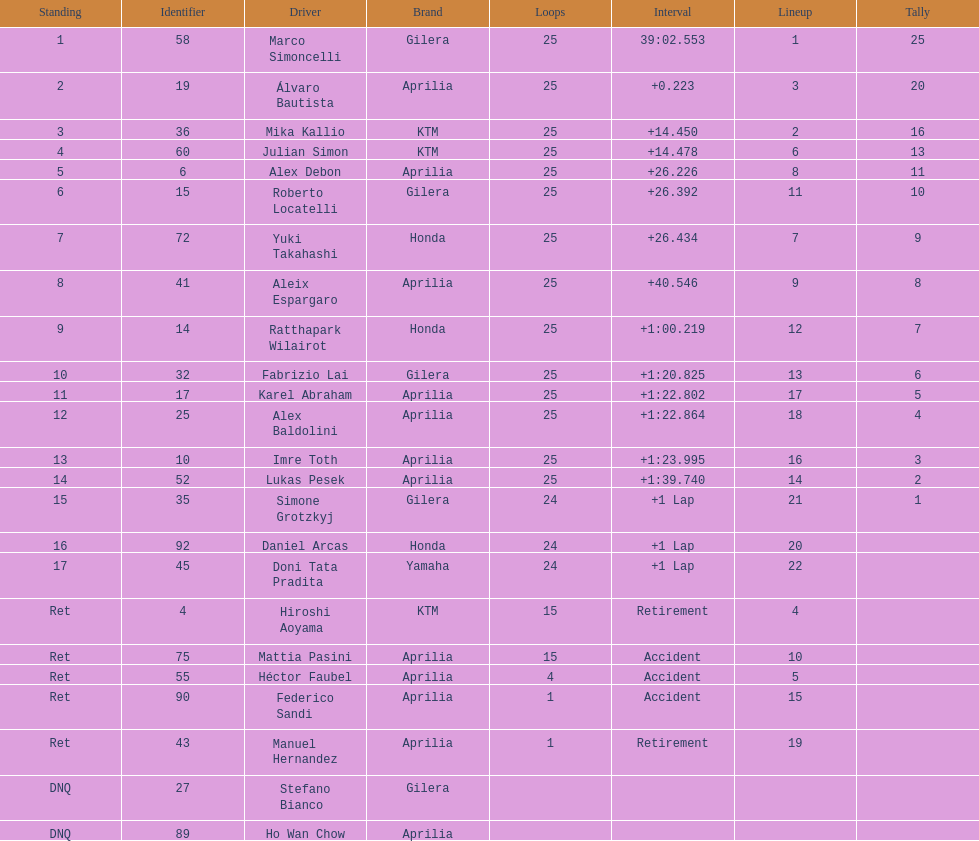Could you help me parse every detail presented in this table? {'header': ['Standing', 'Identifier', 'Driver', 'Brand', 'Loops', 'Interval', 'Lineup', 'Tally'], 'rows': [['1', '58', 'Marco Simoncelli', 'Gilera', '25', '39:02.553', '1', '25'], ['2', '19', 'Álvaro Bautista', 'Aprilia', '25', '+0.223', '3', '20'], ['3', '36', 'Mika Kallio', 'KTM', '25', '+14.450', '2', '16'], ['4', '60', 'Julian Simon', 'KTM', '25', '+14.478', '6', '13'], ['5', '6', 'Alex Debon', 'Aprilia', '25', '+26.226', '8', '11'], ['6', '15', 'Roberto Locatelli', 'Gilera', '25', '+26.392', '11', '10'], ['7', '72', 'Yuki Takahashi', 'Honda', '25', '+26.434', '7', '9'], ['8', '41', 'Aleix Espargaro', 'Aprilia', '25', '+40.546', '9', '8'], ['9', '14', 'Ratthapark Wilairot', 'Honda', '25', '+1:00.219', '12', '7'], ['10', '32', 'Fabrizio Lai', 'Gilera', '25', '+1:20.825', '13', '6'], ['11', '17', 'Karel Abraham', 'Aprilia', '25', '+1:22.802', '17', '5'], ['12', '25', 'Alex Baldolini', 'Aprilia', '25', '+1:22.864', '18', '4'], ['13', '10', 'Imre Toth', 'Aprilia', '25', '+1:23.995', '16', '3'], ['14', '52', 'Lukas Pesek', 'Aprilia', '25', '+1:39.740', '14', '2'], ['15', '35', 'Simone Grotzkyj', 'Gilera', '24', '+1 Lap', '21', '1'], ['16', '92', 'Daniel Arcas', 'Honda', '24', '+1 Lap', '20', ''], ['17', '45', 'Doni Tata Pradita', 'Yamaha', '24', '+1 Lap', '22', ''], ['Ret', '4', 'Hiroshi Aoyama', 'KTM', '15', 'Retirement', '4', ''], ['Ret', '75', 'Mattia Pasini', 'Aprilia', '15', 'Accident', '10', ''], ['Ret', '55', 'Héctor Faubel', 'Aprilia', '4', 'Accident', '5', ''], ['Ret', '90', 'Federico Sandi', 'Aprilia', '1', 'Accident', '15', ''], ['Ret', '43', 'Manuel Hernandez', 'Aprilia', '1', 'Retirement', '19', ''], ['DNQ', '27', 'Stefano Bianco', 'Gilera', '', '', '', ''], ['DNQ', '89', 'Ho Wan Chow', 'Aprilia', '', '', '', '']]} The total amount of riders who did not qualify 2. 